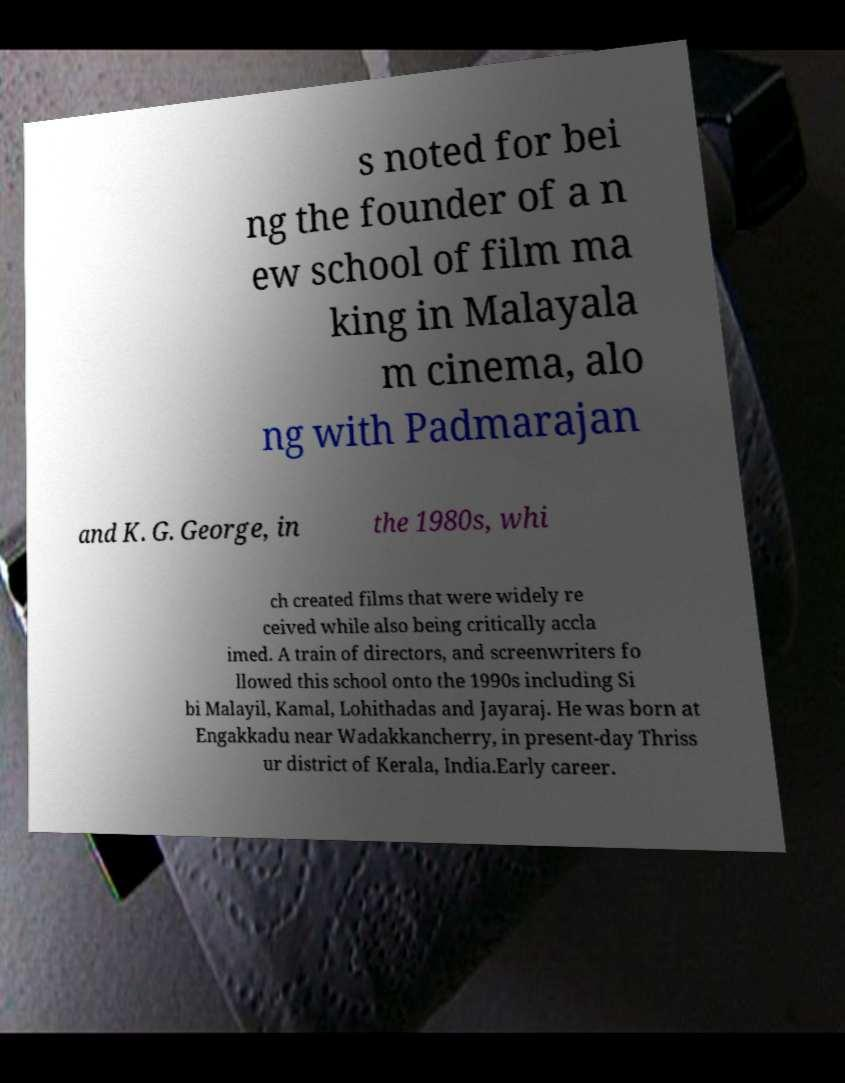Could you assist in decoding the text presented in this image and type it out clearly? s noted for bei ng the founder of a n ew school of film ma king in Malayala m cinema, alo ng with Padmarajan and K. G. George, in the 1980s, whi ch created films that were widely re ceived while also being critically accla imed. A train of directors, and screenwriters fo llowed this school onto the 1990s including Si bi Malayil, Kamal, Lohithadas and Jayaraj. He was born at Engakkadu near Wadakkancherry, in present-day Thriss ur district of Kerala, India.Early career. 